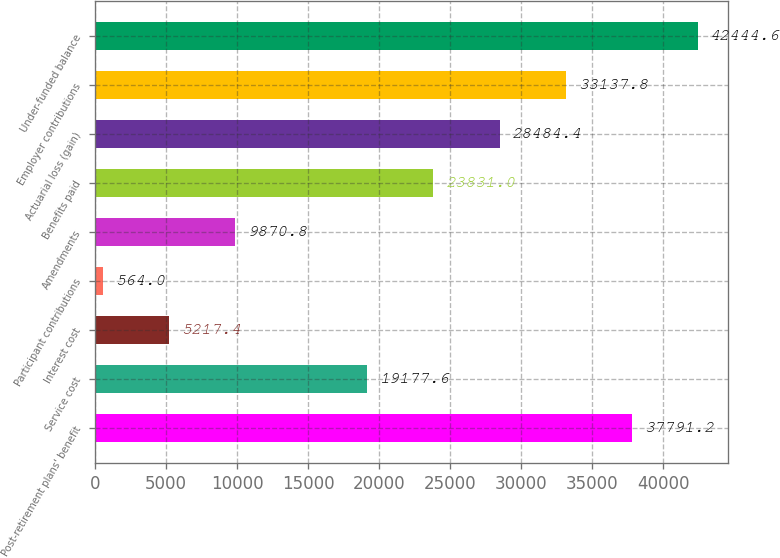Convert chart to OTSL. <chart><loc_0><loc_0><loc_500><loc_500><bar_chart><fcel>Post-retirement plans' benefit<fcel>Service cost<fcel>Interest cost<fcel>Participant contributions<fcel>Amendments<fcel>Benefits paid<fcel>Actuarial loss (gain)<fcel>Employer contributions<fcel>Under-funded balance<nl><fcel>37791.2<fcel>19177.6<fcel>5217.4<fcel>564<fcel>9870.8<fcel>23831<fcel>28484.4<fcel>33137.8<fcel>42444.6<nl></chart> 